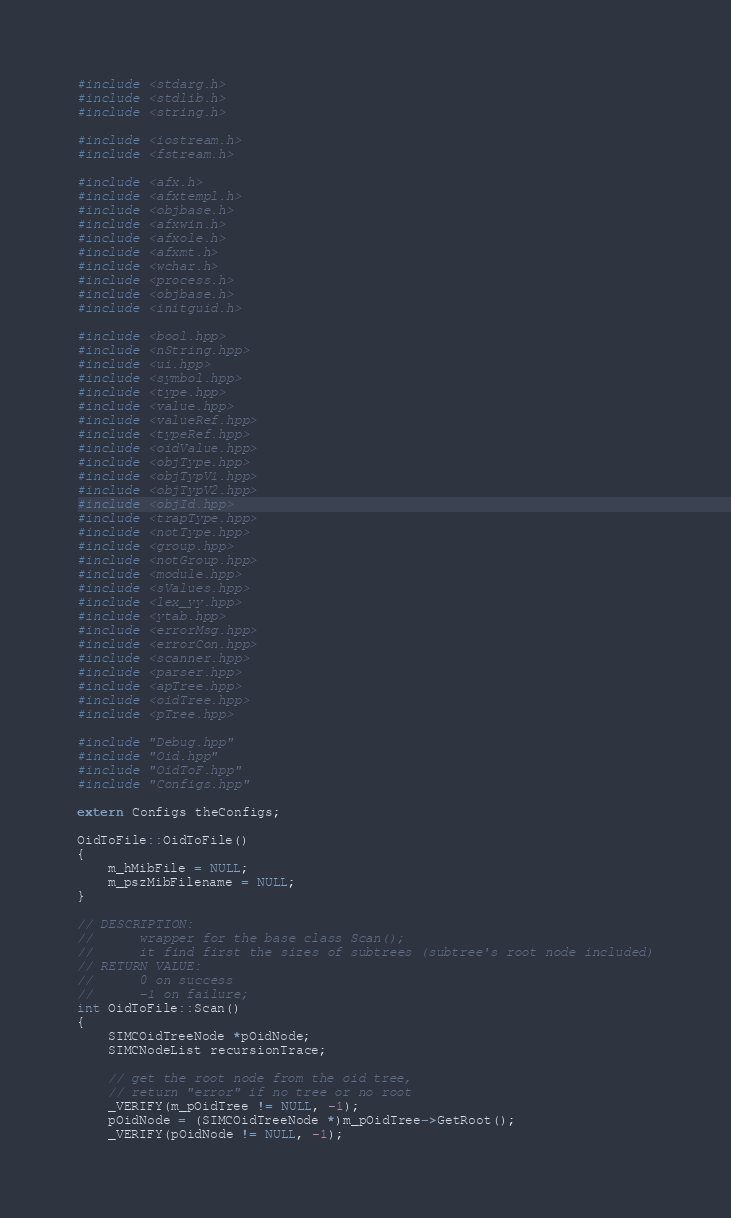Convert code to text. <code><loc_0><loc_0><loc_500><loc_500><_C++_>#include <stdarg.h>
#include <stdlib.h>
#include <string.h>

#include <iostream.h>
#include <fstream.h>

#include <afx.h>
#include <afxtempl.h>
#include <objbase.h>
#include <afxwin.h>
#include <afxole.h>
#include <afxmt.h>
#include <wchar.h>
#include <process.h>
#include <objbase.h>
#include <initguid.h>

#include <bool.hpp>
#include <nString.hpp>
#include <ui.hpp>
#include <symbol.hpp>
#include <type.hpp>
#include <value.hpp>
#include <valueRef.hpp>
#include <typeRef.hpp>
#include <oidValue.hpp>
#include <objType.hpp>
#include <objTypV1.hpp>
#include <objTypV2.hpp>
#include <objId.hpp>
#include <trapType.hpp>
#include <notType.hpp>
#include <group.hpp>
#include <notGroup.hpp>
#include <module.hpp>
#include <sValues.hpp>
#include <lex_yy.hpp>
#include <ytab.hpp>
#include <errorMsg.hpp>
#include <errorCon.hpp>
#include <scanner.hpp>
#include <parser.hpp>
#include <apTree.hpp>
#include <oidTree.hpp>
#include <pTree.hpp>

#include "Debug.hpp"
#include "Oid.hpp"
#include "OidToF.hpp"
#include "Configs.hpp"

extern Configs theConfigs;

OidToFile::OidToFile()
{
	m_hMibFile = NULL;
	m_pszMibFilename = NULL;
}

// DESCRIPTION:
//		wrapper for the base class Scan();
//		it find first the sizes of subtrees (subtree's root node included)
// RETURN VALUE:
//		0 on success
//		-1 on failure;
int OidToFile::Scan()
{
	SIMCOidTreeNode *pOidNode;
	SIMCNodeList recursionTrace;

	// get the root node from the oid tree,
	// return "error" if no tree or no root
	_VERIFY(m_pOidTree != NULL, -1);
	pOidNode = (SIMCOidTreeNode *)m_pOidTree->GetRoot();
	_VERIFY(pOidNode != NULL, -1);
</code> 